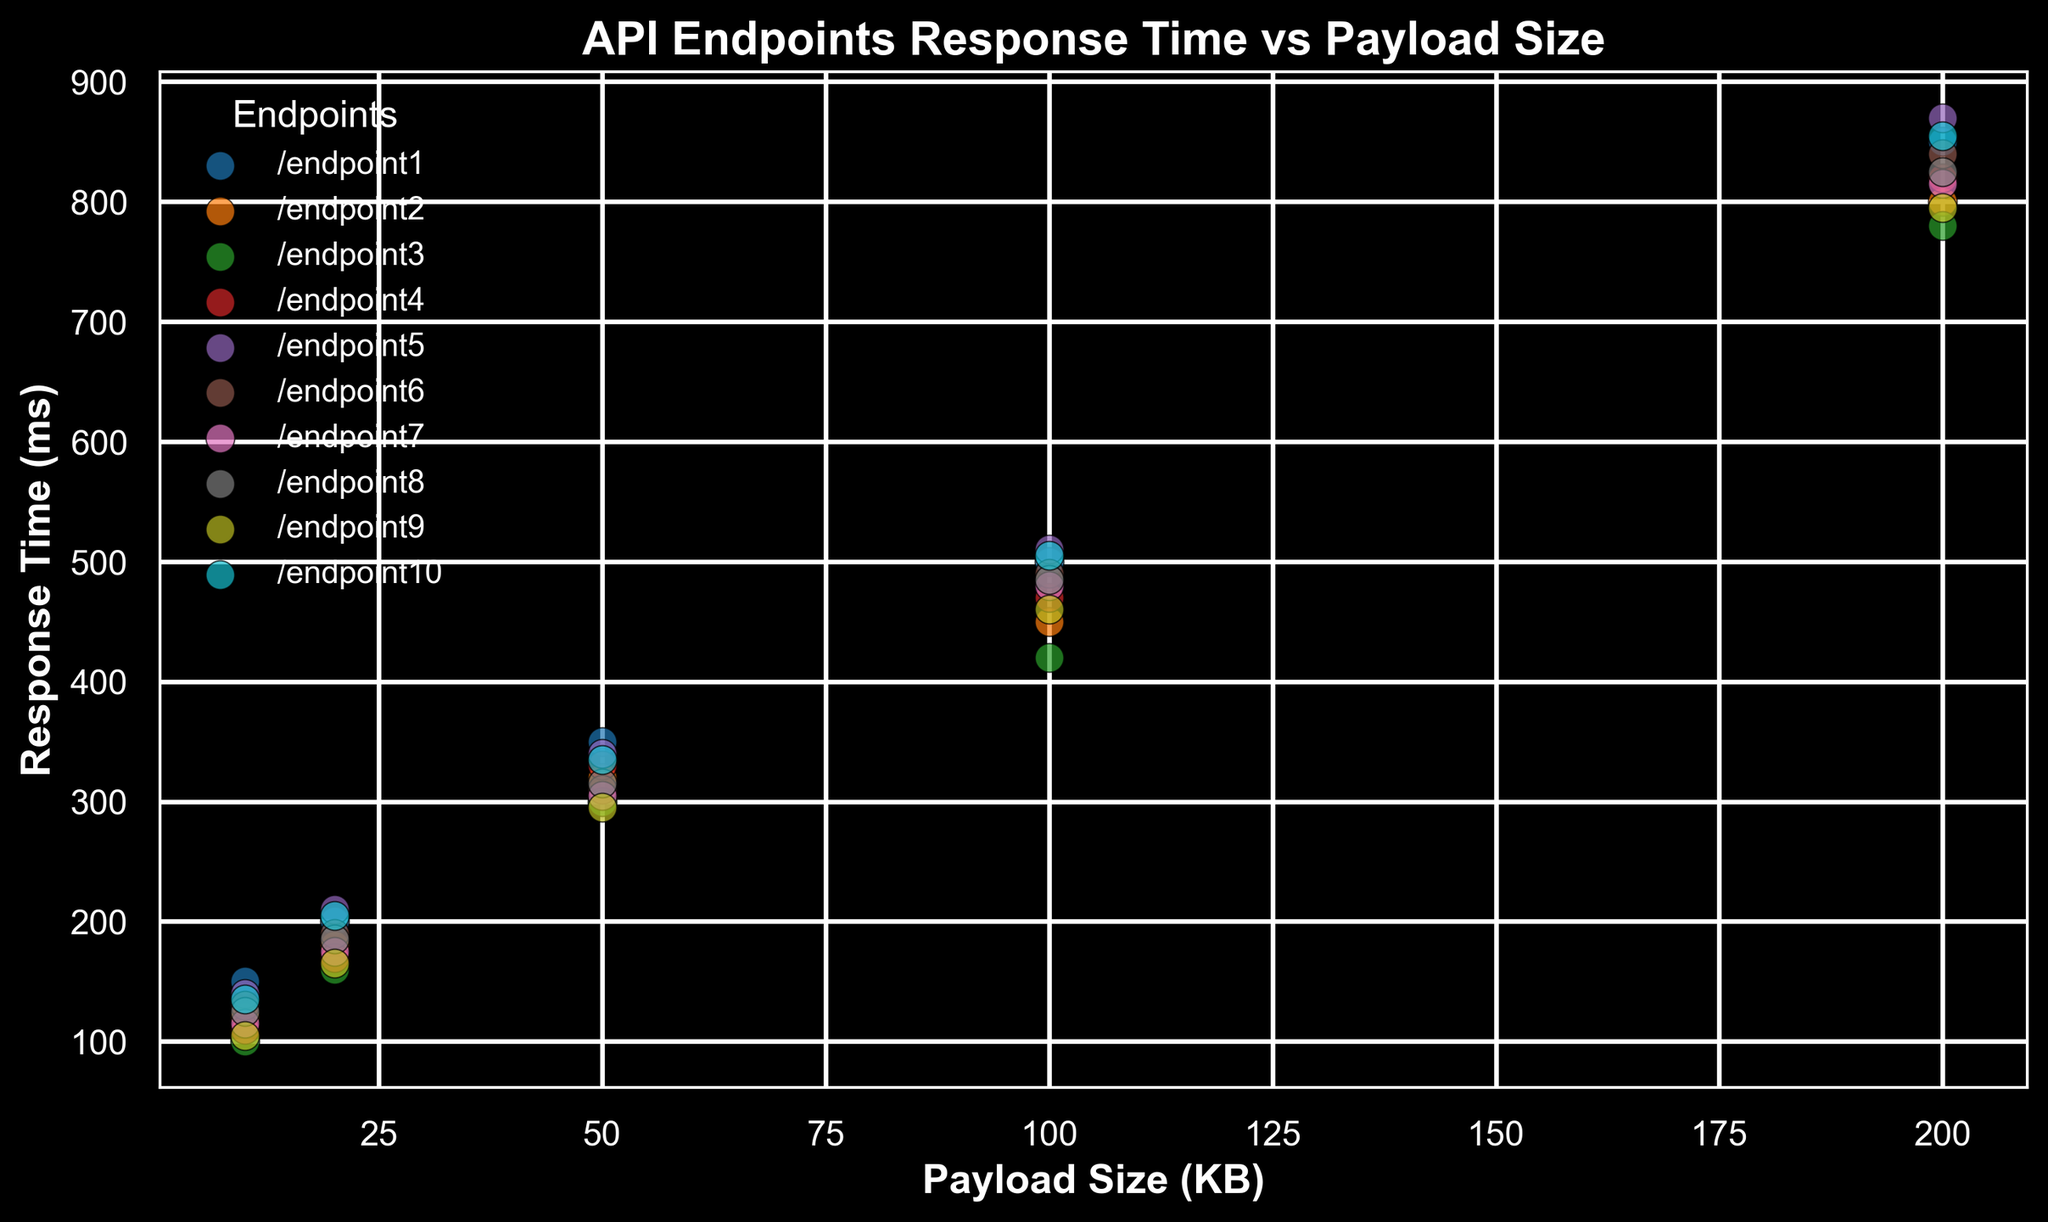Which endpoint has the fastest response time at a 200 KB payload size? By looking at the scatter plot, identify the points corresponding to a 200 KB payload size for each endpoint, then determine which of these points has the lowest response time value. The point closest to the bottom at 200 KB is the fastest.
Answer: `/endpoint9` Which endpoints have approximately the same response time for a 50 KB payload size? Find the scatter points corresponding to a 50 KB payload size. Identify the points that visually align horizontally, meaning they have similar response time values. From the plot, `/endpoint3` and `/endpoint9` seem to have close values.
Answer: `/endpoint3` and `/endpoint9` What is the average response time of all endpoints at a 100 KB payload size? Locate the scatter points for all endpoints at a 100 KB payload size, note their response times, and calculate the average. The response times are (500 + 450 + 420 + 470 + 510 + 490 + 480 + 485 + 460 + 505). The sum is 4670, and the average is 4670/10 = 467.
Answer: 467 ms Which endpoint shows the steepest increase in response time as payload size increases from 10 KB to 100 KB? For each endpoint, observe the change in response time from 10 KB to 100 KB. The endpoint with the largest difference between the smallest payload response time and the 100 KB payload response time indicates the steepest increase. For instance, examine that for `/endpoint1`, the difference is 500 ms - 150 ms = 350 ms. Compare this for each endpoint visually.
Answer: `/endpoint1` Which endpoint has the second fastest response time for a 20 KB payload size? Identify the points corresponding to a 20 KB payload size, sort them visually by response time in ascending order, and note the second point from the bottom.
Answer: `/endpoint9` Which endpoints have response times greater than 800 ms at a 200 KB payload size? Look for points corresponding to a 200 KB payload size that are positioned above the 800 ms mark on the y-axis. Check which endpoints these points belong to.
Answer: `/endpoint1`, `/endpoint5`, `/endpoint6`, `/endpoint10` How does the response time of `/endpoint8` compare to `/endpoint2` for a payload size of 50 KB? Locate the points for a 50 KB payload size for both `/endpoint8` and `/endpoint2`, then compare their y-axis values to determine which one is higher.
Answer: `/endpoint8` is higher What is the difference in response time between the fastest and slowest endpoints at a 50 KB payload size? Find the response times for the 50 KB payload size for all endpoints, determine the minimum and maximum values, and calculate the difference. The fastest is `/endpoint9` with 295 ms, and the slowest is `/endpoint1` with 350 ms. The difference is 350 - 295 = 55 ms.
Answer: 55 ms How many endpoints have a response time of less than 150 ms at a 10 KB payload size? Identify the points for all endpoints at a 10 KB payload size and count how many of these points are below the 150 ms mark on the y-axis.
Answer: 5 endpoints What is the average response time of `/endpoint4` at all payload sizes from 10 KB to 200 KB? List all the response times for `/endpoint4` at the given payload sizes (110, 170, 330, 470, 820). Sum these values: 110 + 170 + 330 + 470 + 820 = 1900. Then, divide by the number of points, which is 5. The average is 1900/5 = 380 ms.
Answer: 380 ms 